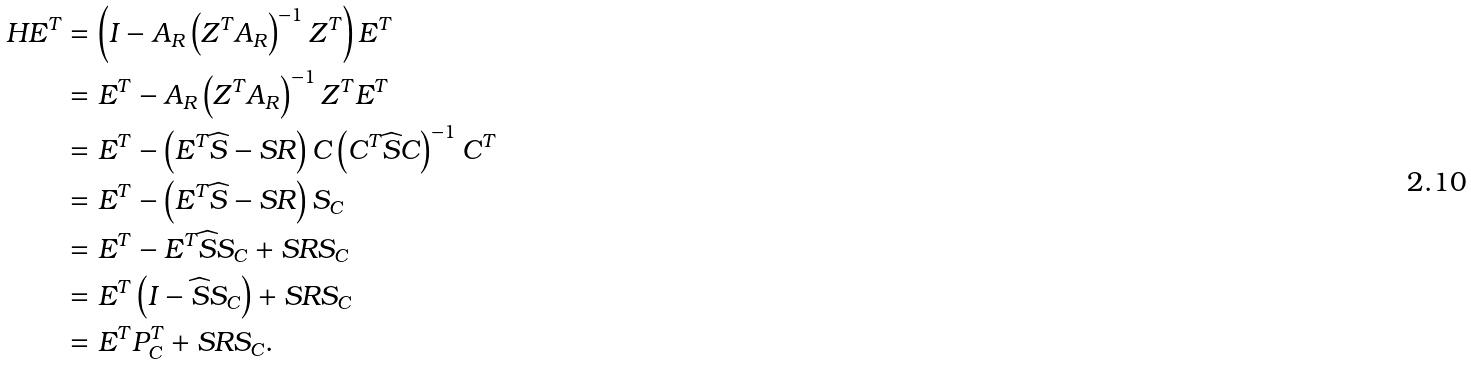<formula> <loc_0><loc_0><loc_500><loc_500>H E ^ { T } & = \left ( I - A _ { R } \left ( Z ^ { T } A _ { R } \right ) ^ { - 1 } Z ^ { T } \right ) E ^ { T } \\ & = E ^ { T } - A _ { R } \left ( Z ^ { T } A _ { R } \right ) ^ { - 1 } Z ^ { T } E ^ { T } \\ & = E ^ { T } - \left ( E ^ { T } \widehat { S } - S R \right ) C \left ( C ^ { T } \widehat { S } C \right ) ^ { - 1 } C ^ { T } \\ & = E ^ { T } - \left ( E ^ { T } \widehat { S } - S R \right ) S _ { C } \\ & = E ^ { T } - E ^ { T } \widehat { S } S _ { C } + S R S _ { C } \\ & = E ^ { T } \left ( I - \widehat { S } S _ { C } \right ) + S R S _ { C } \\ & = E ^ { T } P _ { C } ^ { T } + S R S _ { C } .</formula> 